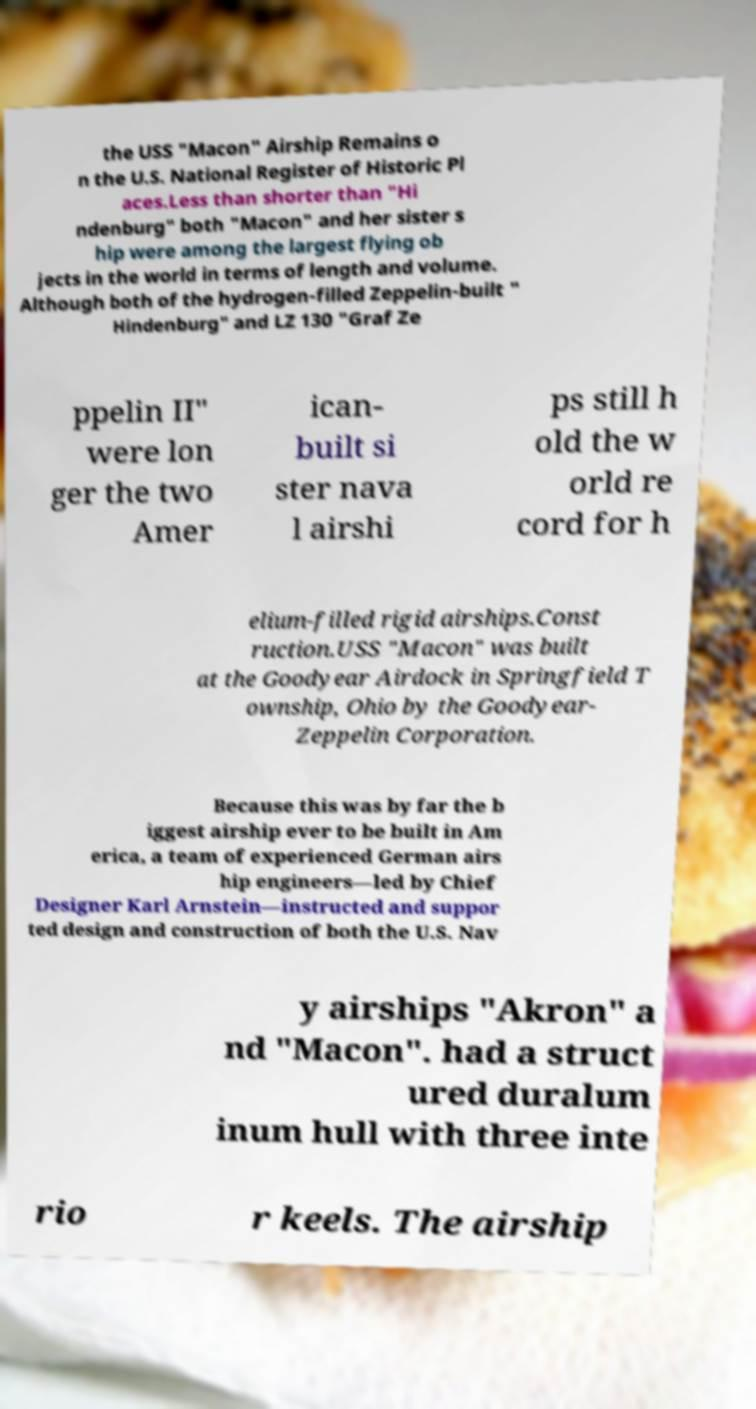Can you accurately transcribe the text from the provided image for me? the USS "Macon" Airship Remains o n the U.S. National Register of Historic Pl aces.Less than shorter than "Hi ndenburg" both "Macon" and her sister s hip were among the largest flying ob jects in the world in terms of length and volume. Although both of the hydrogen-filled Zeppelin-built " Hindenburg" and LZ 130 "Graf Ze ppelin II" were lon ger the two Amer ican- built si ster nava l airshi ps still h old the w orld re cord for h elium-filled rigid airships.Const ruction.USS "Macon" was built at the Goodyear Airdock in Springfield T ownship, Ohio by the Goodyear- Zeppelin Corporation. Because this was by far the b iggest airship ever to be built in Am erica, a team of experienced German airs hip engineers—led by Chief Designer Karl Arnstein—instructed and suppor ted design and construction of both the U.S. Nav y airships "Akron" a nd "Macon". had a struct ured duralum inum hull with three inte rio r keels. The airship 